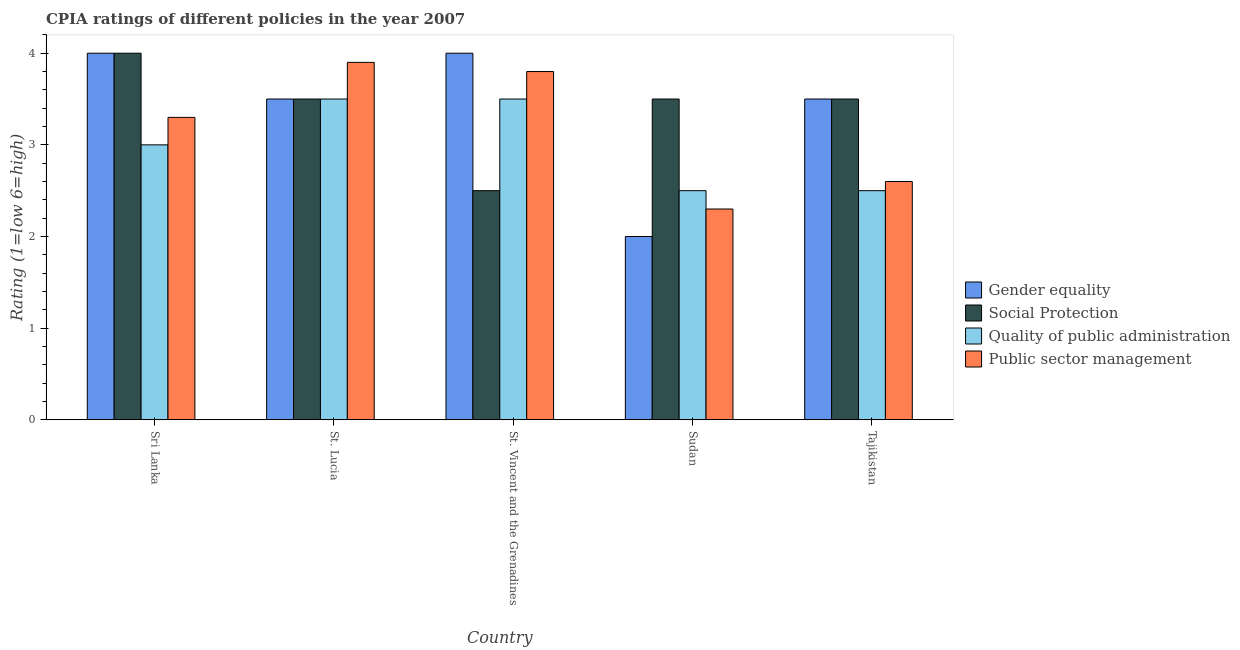How many different coloured bars are there?
Offer a very short reply. 4. Are the number of bars per tick equal to the number of legend labels?
Provide a succinct answer. Yes. How many bars are there on the 1st tick from the right?
Provide a succinct answer. 4. What is the label of the 4th group of bars from the left?
Provide a succinct answer. Sudan. What is the cpia rating of social protection in Sudan?
Keep it short and to the point. 3.5. Across all countries, what is the maximum cpia rating of gender equality?
Ensure brevity in your answer.  4. Across all countries, what is the minimum cpia rating of public sector management?
Make the answer very short. 2.3. In which country was the cpia rating of social protection maximum?
Your answer should be very brief. Sri Lanka. In which country was the cpia rating of gender equality minimum?
Your answer should be compact. Sudan. What is the difference between the cpia rating of public sector management in St. Vincent and the Grenadines and that in Tajikistan?
Your answer should be compact. 1.2. What is the difference between the cpia rating of public sector management in Sri Lanka and the cpia rating of quality of public administration in St. Lucia?
Provide a succinct answer. -0.2. What is the average cpia rating of public sector management per country?
Provide a short and direct response. 3.18. What is the difference between the cpia rating of social protection and cpia rating of gender equality in Sri Lanka?
Offer a very short reply. 0. In how many countries, is the cpia rating of public sector management greater than 4 ?
Make the answer very short. 0. What is the ratio of the cpia rating of social protection in Sri Lanka to that in Sudan?
Your response must be concise. 1.14. Is the cpia rating of gender equality in Sri Lanka less than that in St. Vincent and the Grenadines?
Ensure brevity in your answer.  No. What is the difference between the highest and the second highest cpia rating of social protection?
Offer a very short reply. 0.5. What is the difference between the highest and the lowest cpia rating of public sector management?
Offer a very short reply. 1.6. What does the 3rd bar from the left in St. Vincent and the Grenadines represents?
Give a very brief answer. Quality of public administration. What does the 3rd bar from the right in Tajikistan represents?
Your answer should be compact. Social Protection. How many bars are there?
Provide a succinct answer. 20. Are all the bars in the graph horizontal?
Your answer should be compact. No. Are the values on the major ticks of Y-axis written in scientific E-notation?
Provide a short and direct response. No. Does the graph contain any zero values?
Provide a succinct answer. No. Where does the legend appear in the graph?
Offer a terse response. Center right. How are the legend labels stacked?
Make the answer very short. Vertical. What is the title of the graph?
Give a very brief answer. CPIA ratings of different policies in the year 2007. What is the Rating (1=low 6=high) in Social Protection in Sri Lanka?
Give a very brief answer. 4. What is the Rating (1=low 6=high) in Public sector management in Sri Lanka?
Provide a short and direct response. 3.3. What is the Rating (1=low 6=high) in Social Protection in St. Lucia?
Ensure brevity in your answer.  3.5. What is the Rating (1=low 6=high) in Gender equality in St. Vincent and the Grenadines?
Provide a short and direct response. 4. What is the Rating (1=low 6=high) of Social Protection in St. Vincent and the Grenadines?
Offer a very short reply. 2.5. What is the Rating (1=low 6=high) in Quality of public administration in St. Vincent and the Grenadines?
Offer a terse response. 3.5. What is the Rating (1=low 6=high) of Public sector management in St. Vincent and the Grenadines?
Provide a succinct answer. 3.8. What is the Rating (1=low 6=high) of Gender equality in Sudan?
Provide a short and direct response. 2. What is the Rating (1=low 6=high) in Quality of public administration in Sudan?
Offer a terse response. 2.5. What is the Rating (1=low 6=high) in Gender equality in Tajikistan?
Your answer should be compact. 3.5. What is the Rating (1=low 6=high) in Quality of public administration in Tajikistan?
Ensure brevity in your answer.  2.5. Across all countries, what is the maximum Rating (1=low 6=high) in Gender equality?
Give a very brief answer. 4. Across all countries, what is the maximum Rating (1=low 6=high) of Quality of public administration?
Make the answer very short. 3.5. Across all countries, what is the maximum Rating (1=low 6=high) of Public sector management?
Make the answer very short. 3.9. Across all countries, what is the minimum Rating (1=low 6=high) in Gender equality?
Provide a short and direct response. 2. Across all countries, what is the minimum Rating (1=low 6=high) in Quality of public administration?
Offer a very short reply. 2.5. Across all countries, what is the minimum Rating (1=low 6=high) in Public sector management?
Provide a succinct answer. 2.3. What is the total Rating (1=low 6=high) of Gender equality in the graph?
Give a very brief answer. 17. What is the total Rating (1=low 6=high) of Quality of public administration in the graph?
Give a very brief answer. 15. What is the total Rating (1=low 6=high) of Public sector management in the graph?
Your answer should be compact. 15.9. What is the difference between the Rating (1=low 6=high) of Social Protection in Sri Lanka and that in St. Lucia?
Keep it short and to the point. 0.5. What is the difference between the Rating (1=low 6=high) of Public sector management in Sri Lanka and that in St. Lucia?
Ensure brevity in your answer.  -0.6. What is the difference between the Rating (1=low 6=high) in Quality of public administration in Sri Lanka and that in Sudan?
Provide a succinct answer. 0.5. What is the difference between the Rating (1=low 6=high) of Social Protection in Sri Lanka and that in Tajikistan?
Ensure brevity in your answer.  0.5. What is the difference between the Rating (1=low 6=high) of Gender equality in St. Lucia and that in St. Vincent and the Grenadines?
Give a very brief answer. -0.5. What is the difference between the Rating (1=low 6=high) of Social Protection in St. Lucia and that in St. Vincent and the Grenadines?
Your response must be concise. 1. What is the difference between the Rating (1=low 6=high) in Public sector management in St. Lucia and that in St. Vincent and the Grenadines?
Give a very brief answer. 0.1. What is the difference between the Rating (1=low 6=high) of Social Protection in St. Lucia and that in Sudan?
Offer a very short reply. 0. What is the difference between the Rating (1=low 6=high) of Public sector management in St. Lucia and that in Tajikistan?
Provide a short and direct response. 1.3. What is the difference between the Rating (1=low 6=high) in Quality of public administration in St. Vincent and the Grenadines and that in Sudan?
Offer a terse response. 1. What is the difference between the Rating (1=low 6=high) in Public sector management in St. Vincent and the Grenadines and that in Sudan?
Provide a succinct answer. 1.5. What is the difference between the Rating (1=low 6=high) of Gender equality in St. Vincent and the Grenadines and that in Tajikistan?
Make the answer very short. 0.5. What is the difference between the Rating (1=low 6=high) in Quality of public administration in Sudan and that in Tajikistan?
Your response must be concise. 0. What is the difference between the Rating (1=low 6=high) of Gender equality in Sri Lanka and the Rating (1=low 6=high) of Quality of public administration in St. Lucia?
Your answer should be compact. 0.5. What is the difference between the Rating (1=low 6=high) of Social Protection in Sri Lanka and the Rating (1=low 6=high) of Quality of public administration in St. Lucia?
Give a very brief answer. 0.5. What is the difference between the Rating (1=low 6=high) in Social Protection in Sri Lanka and the Rating (1=low 6=high) in Public sector management in St. Lucia?
Provide a short and direct response. 0.1. What is the difference between the Rating (1=low 6=high) in Quality of public administration in Sri Lanka and the Rating (1=low 6=high) in Public sector management in St. Lucia?
Ensure brevity in your answer.  -0.9. What is the difference between the Rating (1=low 6=high) in Gender equality in Sri Lanka and the Rating (1=low 6=high) in Social Protection in St. Vincent and the Grenadines?
Your response must be concise. 1.5. What is the difference between the Rating (1=low 6=high) of Gender equality in Sri Lanka and the Rating (1=low 6=high) of Quality of public administration in St. Vincent and the Grenadines?
Ensure brevity in your answer.  0.5. What is the difference between the Rating (1=low 6=high) of Gender equality in Sri Lanka and the Rating (1=low 6=high) of Public sector management in St. Vincent and the Grenadines?
Make the answer very short. 0.2. What is the difference between the Rating (1=low 6=high) in Quality of public administration in Sri Lanka and the Rating (1=low 6=high) in Public sector management in St. Vincent and the Grenadines?
Give a very brief answer. -0.8. What is the difference between the Rating (1=low 6=high) of Gender equality in Sri Lanka and the Rating (1=low 6=high) of Social Protection in Sudan?
Offer a terse response. 0.5. What is the difference between the Rating (1=low 6=high) of Gender equality in Sri Lanka and the Rating (1=low 6=high) of Quality of public administration in Sudan?
Ensure brevity in your answer.  1.5. What is the difference between the Rating (1=low 6=high) in Gender equality in Sri Lanka and the Rating (1=low 6=high) in Public sector management in Sudan?
Provide a succinct answer. 1.7. What is the difference between the Rating (1=low 6=high) of Social Protection in Sri Lanka and the Rating (1=low 6=high) of Quality of public administration in Sudan?
Ensure brevity in your answer.  1.5. What is the difference between the Rating (1=low 6=high) in Social Protection in Sri Lanka and the Rating (1=low 6=high) in Public sector management in Sudan?
Your answer should be compact. 1.7. What is the difference between the Rating (1=low 6=high) in Gender equality in Sri Lanka and the Rating (1=low 6=high) in Social Protection in Tajikistan?
Your answer should be compact. 0.5. What is the difference between the Rating (1=low 6=high) in Gender equality in Sri Lanka and the Rating (1=low 6=high) in Quality of public administration in Tajikistan?
Provide a short and direct response. 1.5. What is the difference between the Rating (1=low 6=high) in Social Protection in Sri Lanka and the Rating (1=low 6=high) in Public sector management in Tajikistan?
Provide a short and direct response. 1.4. What is the difference between the Rating (1=low 6=high) of Gender equality in St. Lucia and the Rating (1=low 6=high) of Public sector management in St. Vincent and the Grenadines?
Ensure brevity in your answer.  -0.3. What is the difference between the Rating (1=low 6=high) in Gender equality in St. Lucia and the Rating (1=low 6=high) in Social Protection in Sudan?
Ensure brevity in your answer.  0. What is the difference between the Rating (1=low 6=high) of Gender equality in St. Lucia and the Rating (1=low 6=high) of Quality of public administration in Tajikistan?
Provide a short and direct response. 1. What is the difference between the Rating (1=low 6=high) of Quality of public administration in St. Lucia and the Rating (1=low 6=high) of Public sector management in Tajikistan?
Keep it short and to the point. 0.9. What is the difference between the Rating (1=low 6=high) in Gender equality in St. Vincent and the Grenadines and the Rating (1=low 6=high) in Quality of public administration in Sudan?
Offer a very short reply. 1.5. What is the difference between the Rating (1=low 6=high) in Gender equality in St. Vincent and the Grenadines and the Rating (1=low 6=high) in Public sector management in Sudan?
Your response must be concise. 1.7. What is the difference between the Rating (1=low 6=high) of Social Protection in St. Vincent and the Grenadines and the Rating (1=low 6=high) of Public sector management in Sudan?
Provide a short and direct response. 0.2. What is the difference between the Rating (1=low 6=high) of Quality of public administration in St. Vincent and the Grenadines and the Rating (1=low 6=high) of Public sector management in Sudan?
Your answer should be very brief. 1.2. What is the difference between the Rating (1=low 6=high) in Gender equality in St. Vincent and the Grenadines and the Rating (1=low 6=high) in Quality of public administration in Tajikistan?
Ensure brevity in your answer.  1.5. What is the difference between the Rating (1=low 6=high) in Social Protection in St. Vincent and the Grenadines and the Rating (1=low 6=high) in Quality of public administration in Tajikistan?
Provide a short and direct response. 0. What is the difference between the Rating (1=low 6=high) of Gender equality in Sudan and the Rating (1=low 6=high) of Quality of public administration in Tajikistan?
Your answer should be compact. -0.5. What is the difference between the Rating (1=low 6=high) of Social Protection in Sudan and the Rating (1=low 6=high) of Public sector management in Tajikistan?
Make the answer very short. 0.9. What is the average Rating (1=low 6=high) of Public sector management per country?
Offer a very short reply. 3.18. What is the difference between the Rating (1=low 6=high) in Gender equality and Rating (1=low 6=high) in Public sector management in Sri Lanka?
Your answer should be very brief. 0.7. What is the difference between the Rating (1=low 6=high) in Social Protection and Rating (1=low 6=high) in Quality of public administration in Sri Lanka?
Provide a short and direct response. 1. What is the difference between the Rating (1=low 6=high) of Social Protection and Rating (1=low 6=high) of Public sector management in Sri Lanka?
Offer a very short reply. 0.7. What is the difference between the Rating (1=low 6=high) in Quality of public administration and Rating (1=low 6=high) in Public sector management in Sri Lanka?
Ensure brevity in your answer.  -0.3. What is the difference between the Rating (1=low 6=high) in Gender equality and Rating (1=low 6=high) in Social Protection in St. Lucia?
Your answer should be compact. 0. What is the difference between the Rating (1=low 6=high) in Social Protection and Rating (1=low 6=high) in Quality of public administration in St. Lucia?
Your answer should be compact. 0. What is the difference between the Rating (1=low 6=high) in Gender equality and Rating (1=low 6=high) in Quality of public administration in St. Vincent and the Grenadines?
Make the answer very short. 0.5. What is the difference between the Rating (1=low 6=high) of Social Protection and Rating (1=low 6=high) of Quality of public administration in St. Vincent and the Grenadines?
Your answer should be compact. -1. What is the difference between the Rating (1=low 6=high) of Social Protection and Rating (1=low 6=high) of Public sector management in St. Vincent and the Grenadines?
Provide a succinct answer. -1.3. What is the difference between the Rating (1=low 6=high) in Gender equality and Rating (1=low 6=high) in Social Protection in Sudan?
Keep it short and to the point. -1.5. What is the difference between the Rating (1=low 6=high) of Social Protection and Rating (1=low 6=high) of Public sector management in Sudan?
Your response must be concise. 1.2. What is the difference between the Rating (1=low 6=high) in Gender equality and Rating (1=low 6=high) in Quality of public administration in Tajikistan?
Ensure brevity in your answer.  1. What is the difference between the Rating (1=low 6=high) of Social Protection and Rating (1=low 6=high) of Public sector management in Tajikistan?
Ensure brevity in your answer.  0.9. What is the difference between the Rating (1=low 6=high) in Quality of public administration and Rating (1=low 6=high) in Public sector management in Tajikistan?
Keep it short and to the point. -0.1. What is the ratio of the Rating (1=low 6=high) in Social Protection in Sri Lanka to that in St. Lucia?
Ensure brevity in your answer.  1.14. What is the ratio of the Rating (1=low 6=high) of Quality of public administration in Sri Lanka to that in St. Lucia?
Offer a terse response. 0.86. What is the ratio of the Rating (1=low 6=high) of Public sector management in Sri Lanka to that in St. Lucia?
Provide a succinct answer. 0.85. What is the ratio of the Rating (1=low 6=high) of Gender equality in Sri Lanka to that in St. Vincent and the Grenadines?
Offer a very short reply. 1. What is the ratio of the Rating (1=low 6=high) in Social Protection in Sri Lanka to that in St. Vincent and the Grenadines?
Your answer should be compact. 1.6. What is the ratio of the Rating (1=low 6=high) of Public sector management in Sri Lanka to that in St. Vincent and the Grenadines?
Your answer should be very brief. 0.87. What is the ratio of the Rating (1=low 6=high) of Public sector management in Sri Lanka to that in Sudan?
Keep it short and to the point. 1.43. What is the ratio of the Rating (1=low 6=high) of Gender equality in Sri Lanka to that in Tajikistan?
Provide a succinct answer. 1.14. What is the ratio of the Rating (1=low 6=high) of Social Protection in Sri Lanka to that in Tajikistan?
Your answer should be very brief. 1.14. What is the ratio of the Rating (1=low 6=high) of Quality of public administration in Sri Lanka to that in Tajikistan?
Give a very brief answer. 1.2. What is the ratio of the Rating (1=low 6=high) in Public sector management in Sri Lanka to that in Tajikistan?
Your answer should be compact. 1.27. What is the ratio of the Rating (1=low 6=high) in Gender equality in St. Lucia to that in St. Vincent and the Grenadines?
Your response must be concise. 0.88. What is the ratio of the Rating (1=low 6=high) in Social Protection in St. Lucia to that in St. Vincent and the Grenadines?
Offer a terse response. 1.4. What is the ratio of the Rating (1=low 6=high) in Quality of public administration in St. Lucia to that in St. Vincent and the Grenadines?
Offer a very short reply. 1. What is the ratio of the Rating (1=low 6=high) in Public sector management in St. Lucia to that in St. Vincent and the Grenadines?
Your answer should be compact. 1.03. What is the ratio of the Rating (1=low 6=high) of Public sector management in St. Lucia to that in Sudan?
Your answer should be very brief. 1.7. What is the ratio of the Rating (1=low 6=high) in Gender equality in St. Lucia to that in Tajikistan?
Provide a short and direct response. 1. What is the ratio of the Rating (1=low 6=high) in Quality of public administration in St. Lucia to that in Tajikistan?
Your response must be concise. 1.4. What is the ratio of the Rating (1=low 6=high) of Public sector management in St. Lucia to that in Tajikistan?
Your response must be concise. 1.5. What is the ratio of the Rating (1=low 6=high) of Gender equality in St. Vincent and the Grenadines to that in Sudan?
Make the answer very short. 2. What is the ratio of the Rating (1=low 6=high) in Social Protection in St. Vincent and the Grenadines to that in Sudan?
Keep it short and to the point. 0.71. What is the ratio of the Rating (1=low 6=high) of Quality of public administration in St. Vincent and the Grenadines to that in Sudan?
Your answer should be compact. 1.4. What is the ratio of the Rating (1=low 6=high) of Public sector management in St. Vincent and the Grenadines to that in Sudan?
Provide a short and direct response. 1.65. What is the ratio of the Rating (1=low 6=high) in Public sector management in St. Vincent and the Grenadines to that in Tajikistan?
Keep it short and to the point. 1.46. What is the ratio of the Rating (1=low 6=high) of Public sector management in Sudan to that in Tajikistan?
Offer a terse response. 0.88. What is the difference between the highest and the second highest Rating (1=low 6=high) in Gender equality?
Your response must be concise. 0. What is the difference between the highest and the lowest Rating (1=low 6=high) in Social Protection?
Offer a terse response. 1.5. What is the difference between the highest and the lowest Rating (1=low 6=high) of Quality of public administration?
Provide a succinct answer. 1. What is the difference between the highest and the lowest Rating (1=low 6=high) in Public sector management?
Offer a terse response. 1.6. 